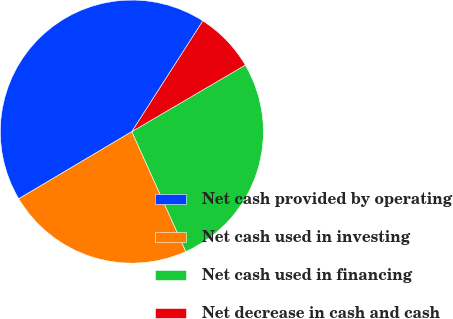Convert chart to OTSL. <chart><loc_0><loc_0><loc_500><loc_500><pie_chart><fcel>Net cash provided by operating<fcel>Net cash used in investing<fcel>Net cash used in financing<fcel>Net decrease in cash and cash<nl><fcel>42.6%<fcel>23.2%<fcel>26.71%<fcel>7.48%<nl></chart> 